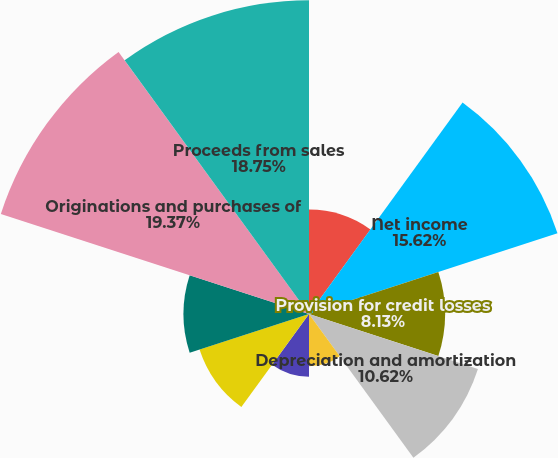Convert chart to OTSL. <chart><loc_0><loc_0><loc_500><loc_500><pie_chart><fcel>Year ended December 31 (in<fcel>Net income<fcel>Provision for credit losses<fcel>Depreciation and amortization<fcel>Amortization of intangibles<fcel>Deferred tax expense/(benefit)<fcel>Investment securities gains<fcel>Stock-based compensation<fcel>Originations and purchases of<fcel>Proceeds from sales<nl><fcel>6.25%<fcel>15.62%<fcel>8.13%<fcel>10.62%<fcel>3.13%<fcel>3.75%<fcel>6.88%<fcel>7.5%<fcel>19.37%<fcel>18.75%<nl></chart> 